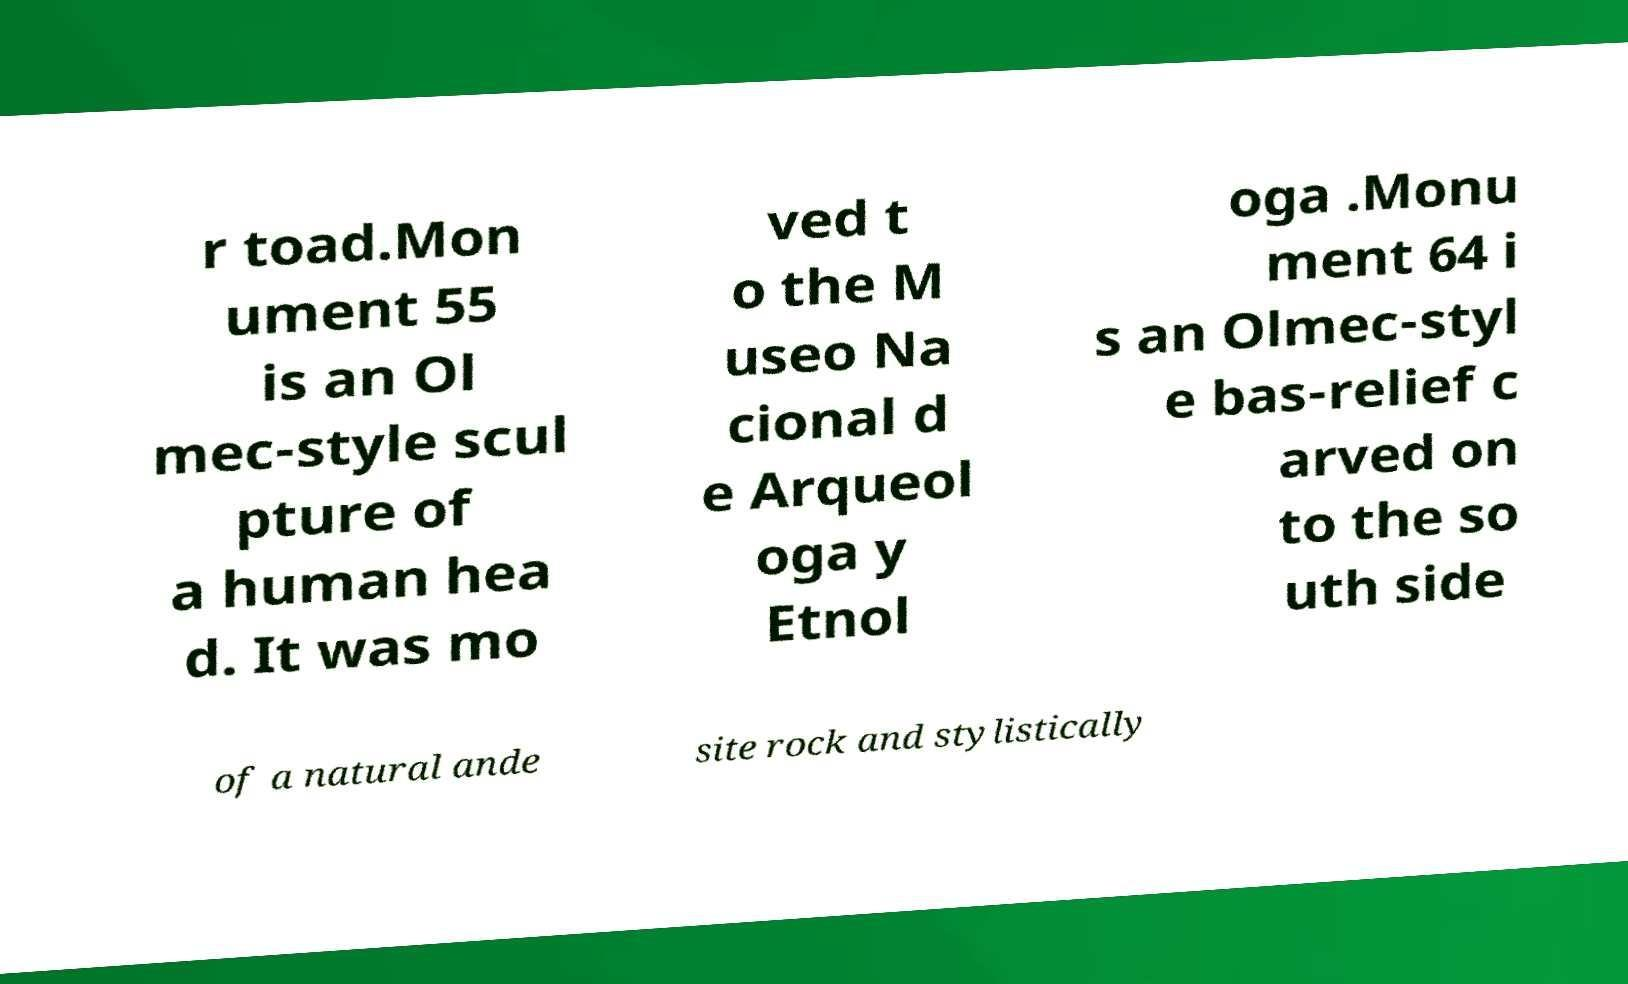What messages or text are displayed in this image? I need them in a readable, typed format. r toad.Mon ument 55 is an Ol mec-style scul pture of a human hea d. It was mo ved t o the M useo Na cional d e Arqueol oga y Etnol oga .Monu ment 64 i s an Olmec-styl e bas-relief c arved on to the so uth side of a natural ande site rock and stylistically 